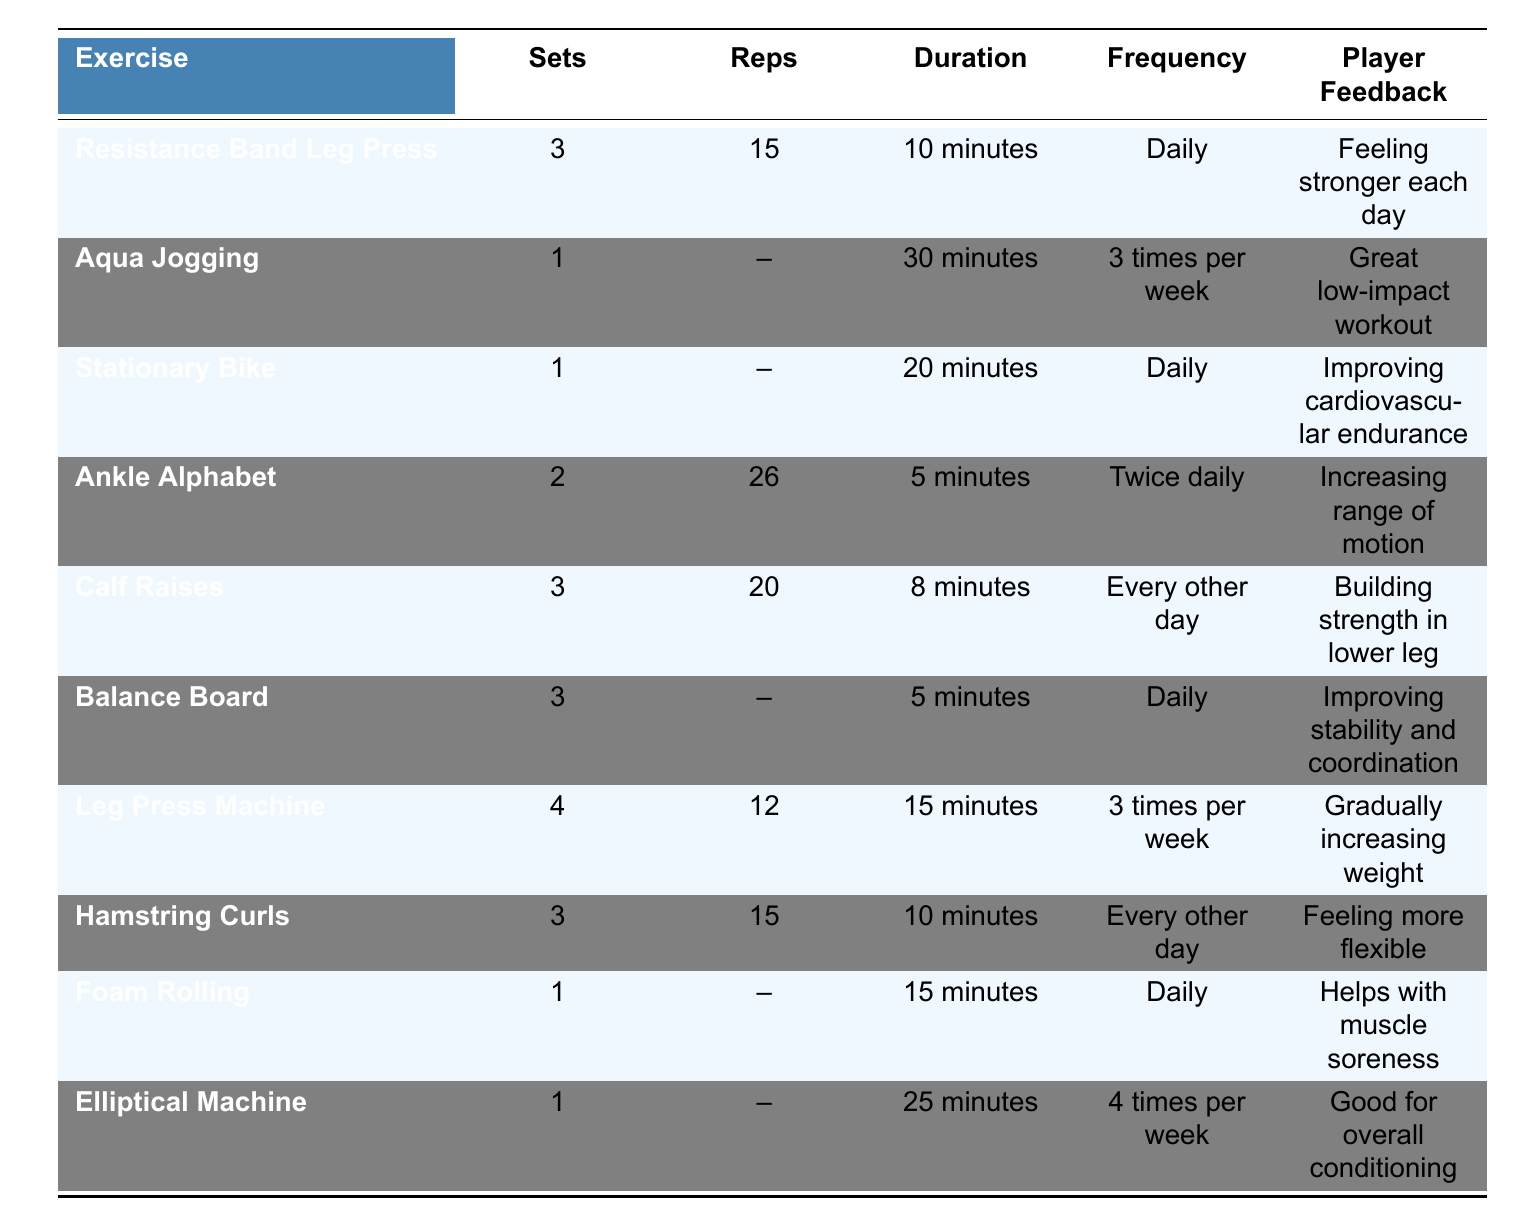What is the duration of the Aqua Jogging exercise? The table lists the duration of the Aqua Jogging exercise as "30 minutes."
Answer: 30 minutes How many sets are performed for the Calf Raises exercise? According to the table, the Calf Raises exercise has 3 sets.
Answer: 3 sets Is the player doing Ankle Alphabet exercises every day? The frequency for Ankle Alphabet exercises in the table indicates they are performed "Twice daily," which means it is done every day.
Answer: Yes What is the total number of sets for all exercises combined? To find the total number of sets, we simply add the sets for each exercise: 3 (Resistance Band Leg Press) + 1 (Aqua Jogging) + 1 (Stationary Bike) + 2 (Ankle Alphabet) + 3 (Calf Raises) + 3 (Balance Board) + 4 (Leg Press Machine) + 3 (Hamstring Curls) + 1 (Foam Rolling) + 1 (Elliptical Machine) = 22 sets.
Answer: 22 sets Which exercise has the highest number of repetitions? The exercise with the highest number of repetitions is the Ankle Alphabet with 26 repetitions.
Answer: Ankle Alphabet How often does the player perform the Balance Board exercise compared to the Stationary Bike? The Balance Board is performed daily, while the Stationary Bike is also performed daily. Since both are daily, they have the same frequency of performance.
Answer: Same frequency Are there any exercises that have no specified repetitions? If so, how many? The table shows the Balance Board, Aqua Jogging, Stationary Bike, and Foam Rolling exercises have no specified repetitions. Counting them, there are 4 exercises without specified repetitions.
Answer: 4 exercises Which exercise is performed the least in terms of sets? The exercise performed the least in terms of sets is Aqua Jogging with only 1 set.
Answer: Aqua Jogging What feedback did the player provide for the Leg Press Machine? The player's feedback for the Leg Press Machine is "Gradually increasing weight."
Answer: Gradually increasing weight How many types of exercises are performed daily? The types of exercises performed daily include Resistance Band Leg Press, Stationary Bike, Ankle Alphabet, Balance Board, and Foam Rolling, totaling 5 exercises.
Answer: 5 exercises 